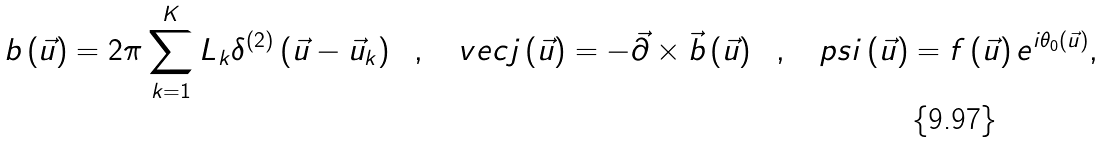<formula> <loc_0><loc_0><loc_500><loc_500>b \left ( \vec { u } \right ) = 2 \pi \sum _ { k = 1 } ^ { K } L _ { k } \delta ^ { ( 2 ) } \left ( \vec { u } - \vec { u } _ { k } \right ) \ \ , \ \ \ v e c { j } \left ( \vec { u } \right ) = - \vec { \partial } \times \vec { b } \left ( \vec { u } \right ) \ \ , \ \ \ p s i \left ( \vec { u } \right ) = f \left ( \vec { u } \right ) e ^ { i \theta _ { 0 } ( \vec { u } ) } ,</formula> 